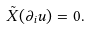<formula> <loc_0><loc_0><loc_500><loc_500>\tilde { X } ( \partial _ { i } u ) = 0 .</formula> 